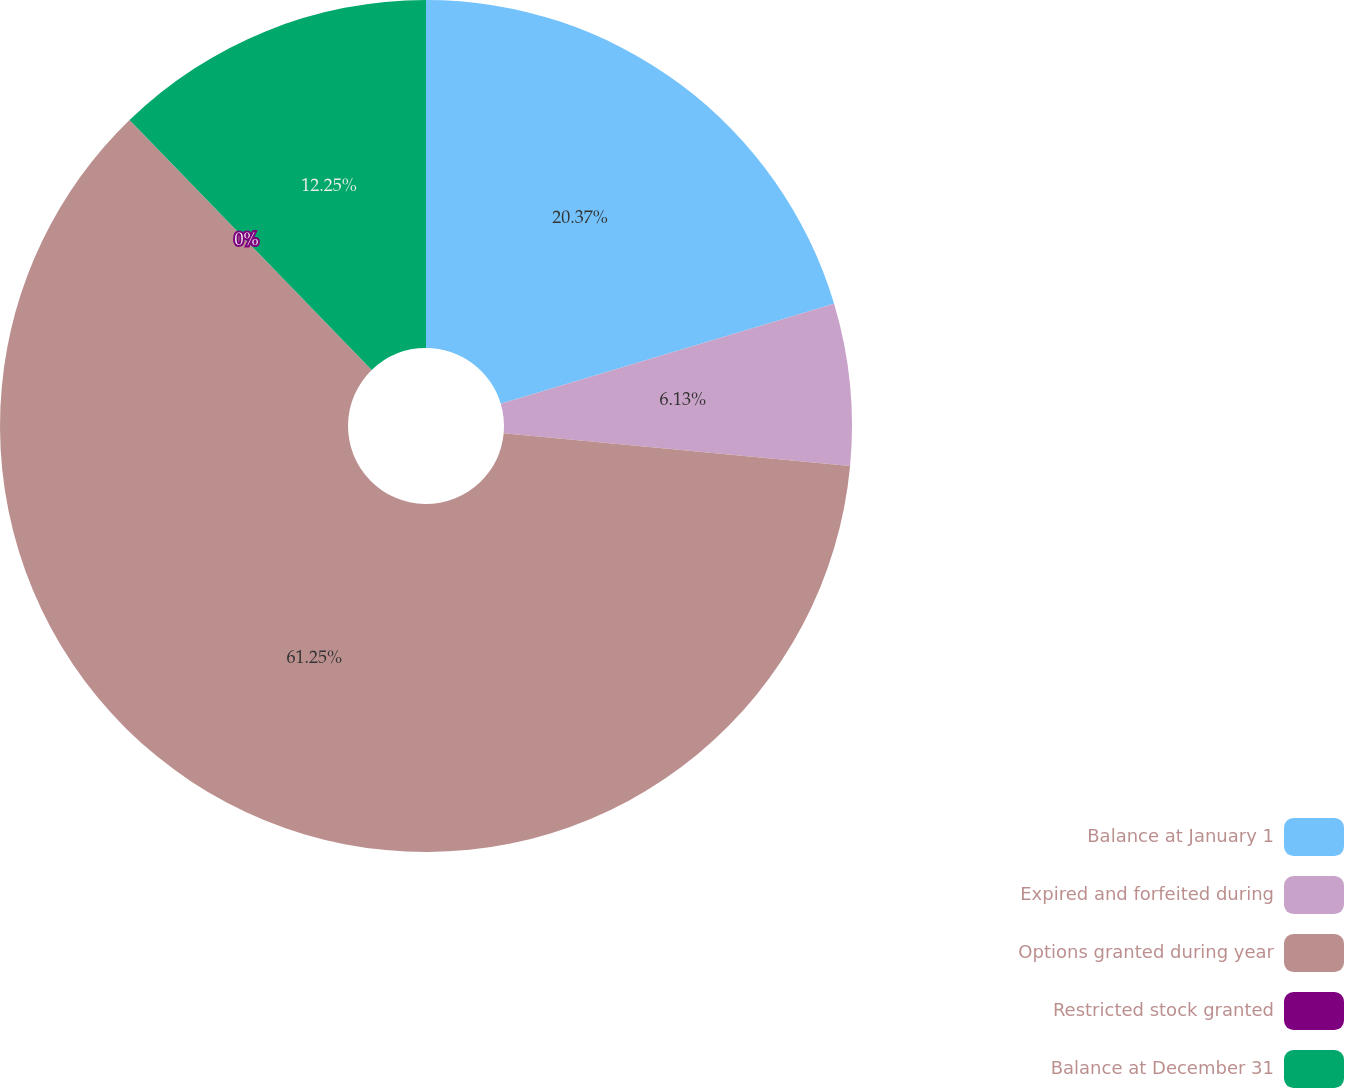Convert chart to OTSL. <chart><loc_0><loc_0><loc_500><loc_500><pie_chart><fcel>Balance at January 1<fcel>Expired and forfeited during<fcel>Options granted during year<fcel>Restricted stock granted<fcel>Balance at December 31<nl><fcel>20.37%<fcel>6.13%<fcel>61.25%<fcel>0.0%<fcel>12.25%<nl></chart> 